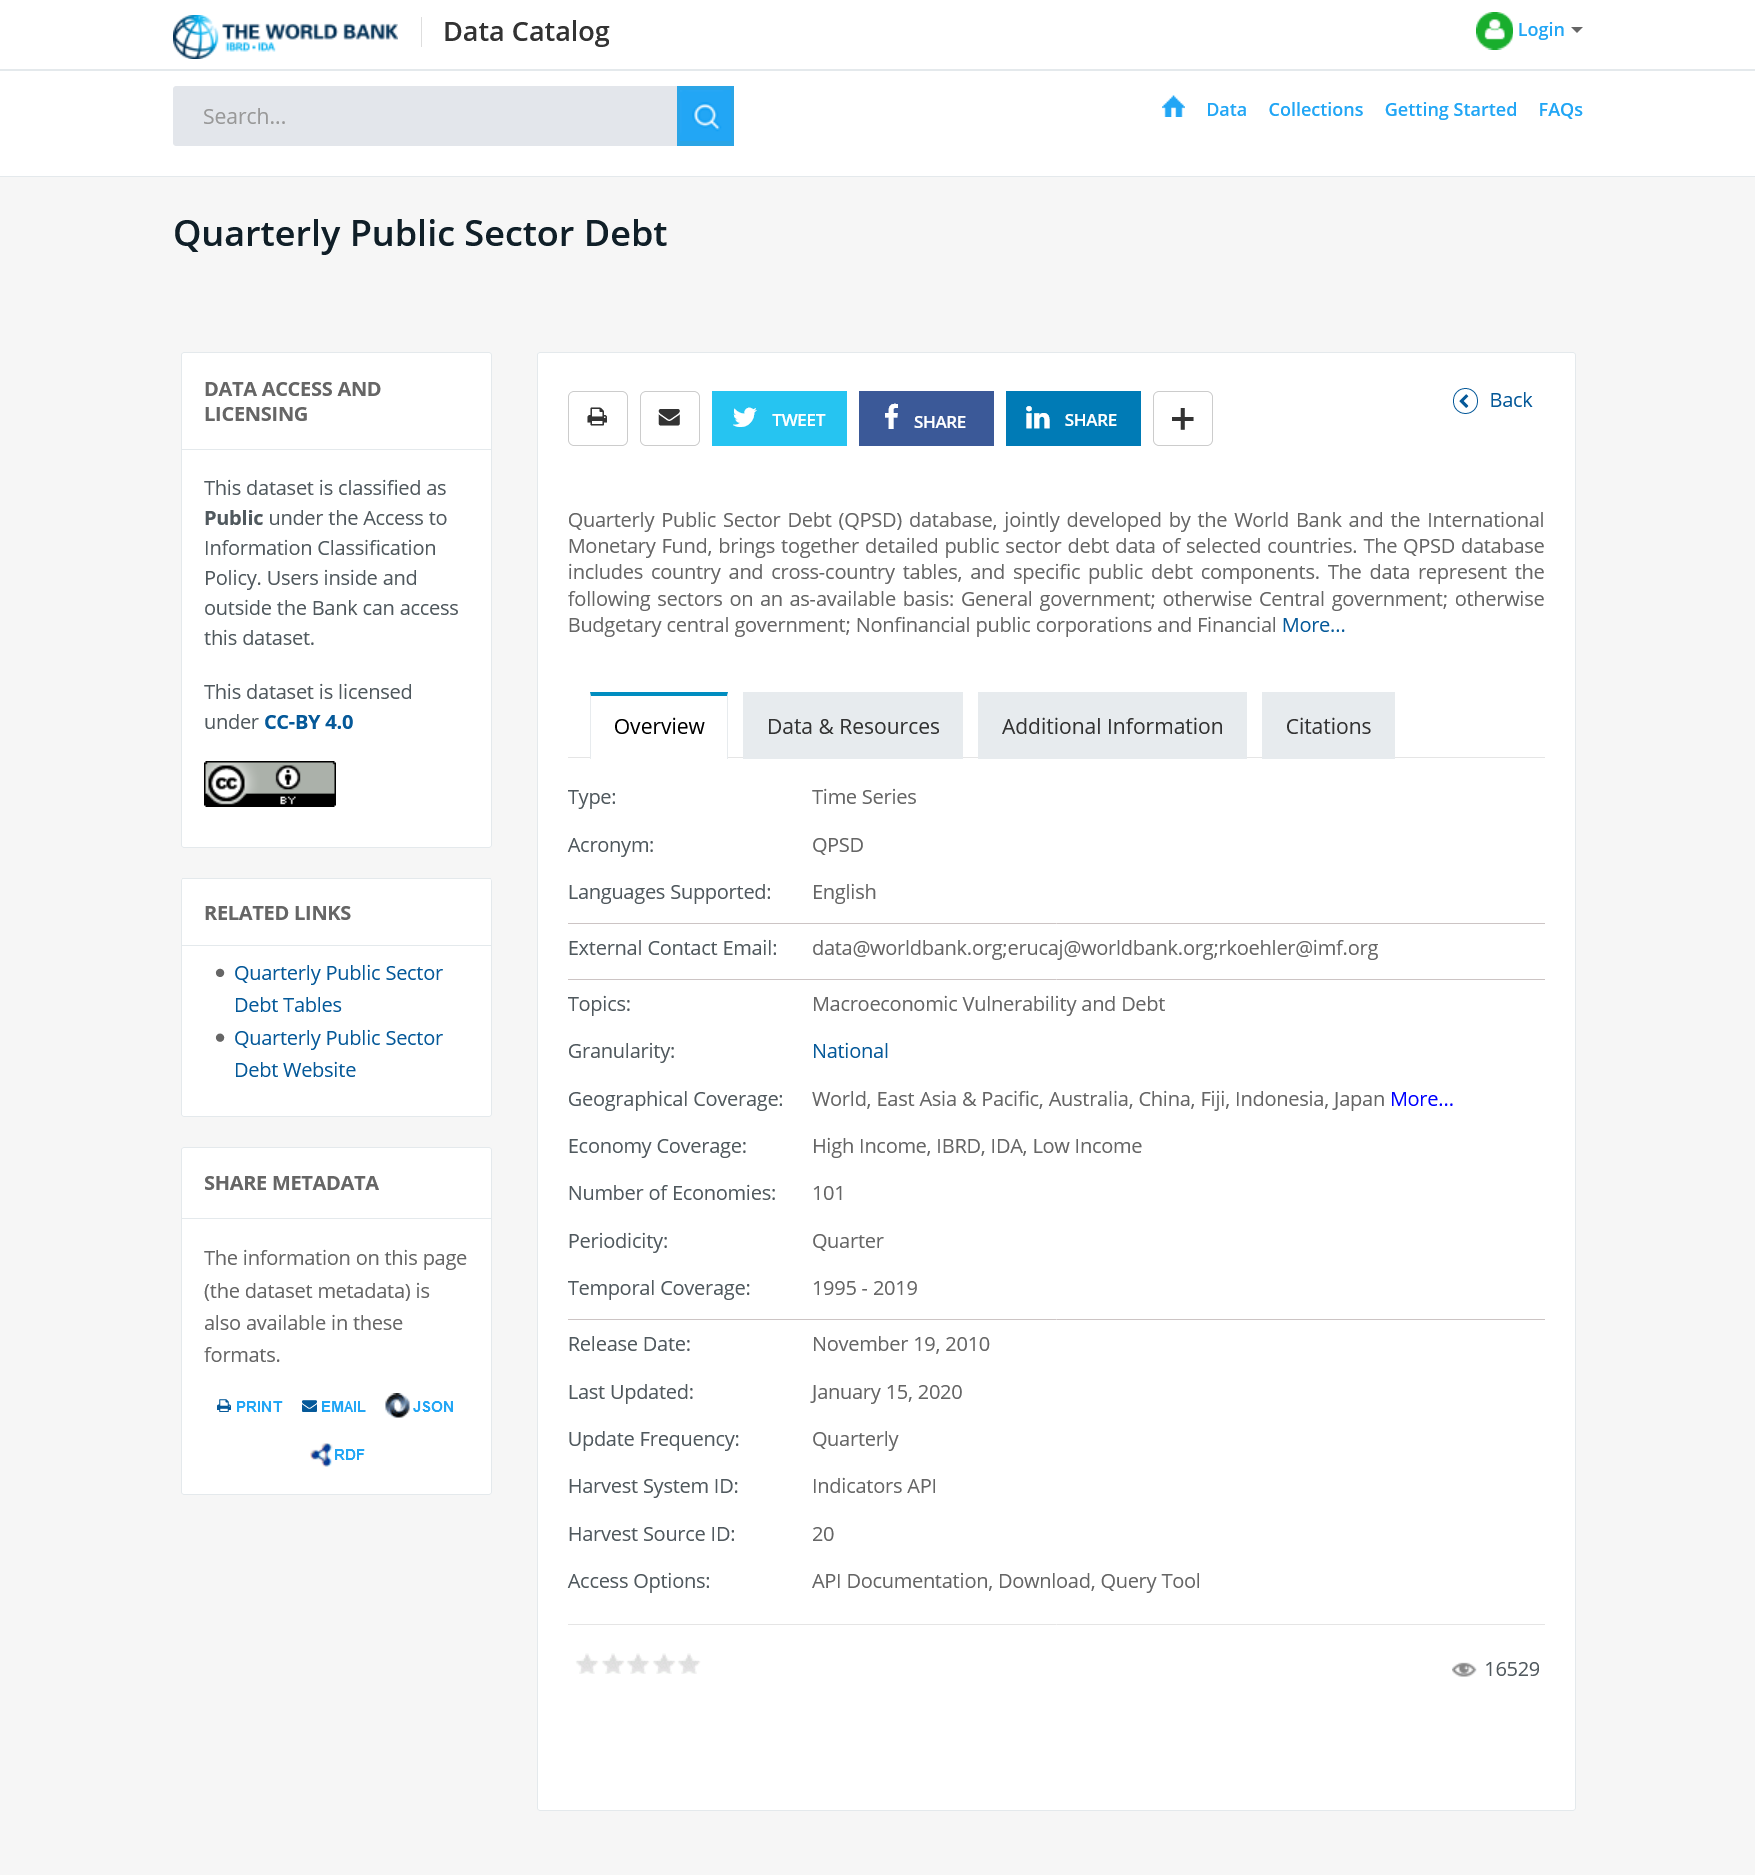Outline some significant characteristics in this image. The QPSD includes cross-country tables. The Quarterly Public Sector Debt database is publicly available. The Quarterly Public Sector Debt database was developed by the World Bank and the International Monetary Fund. 